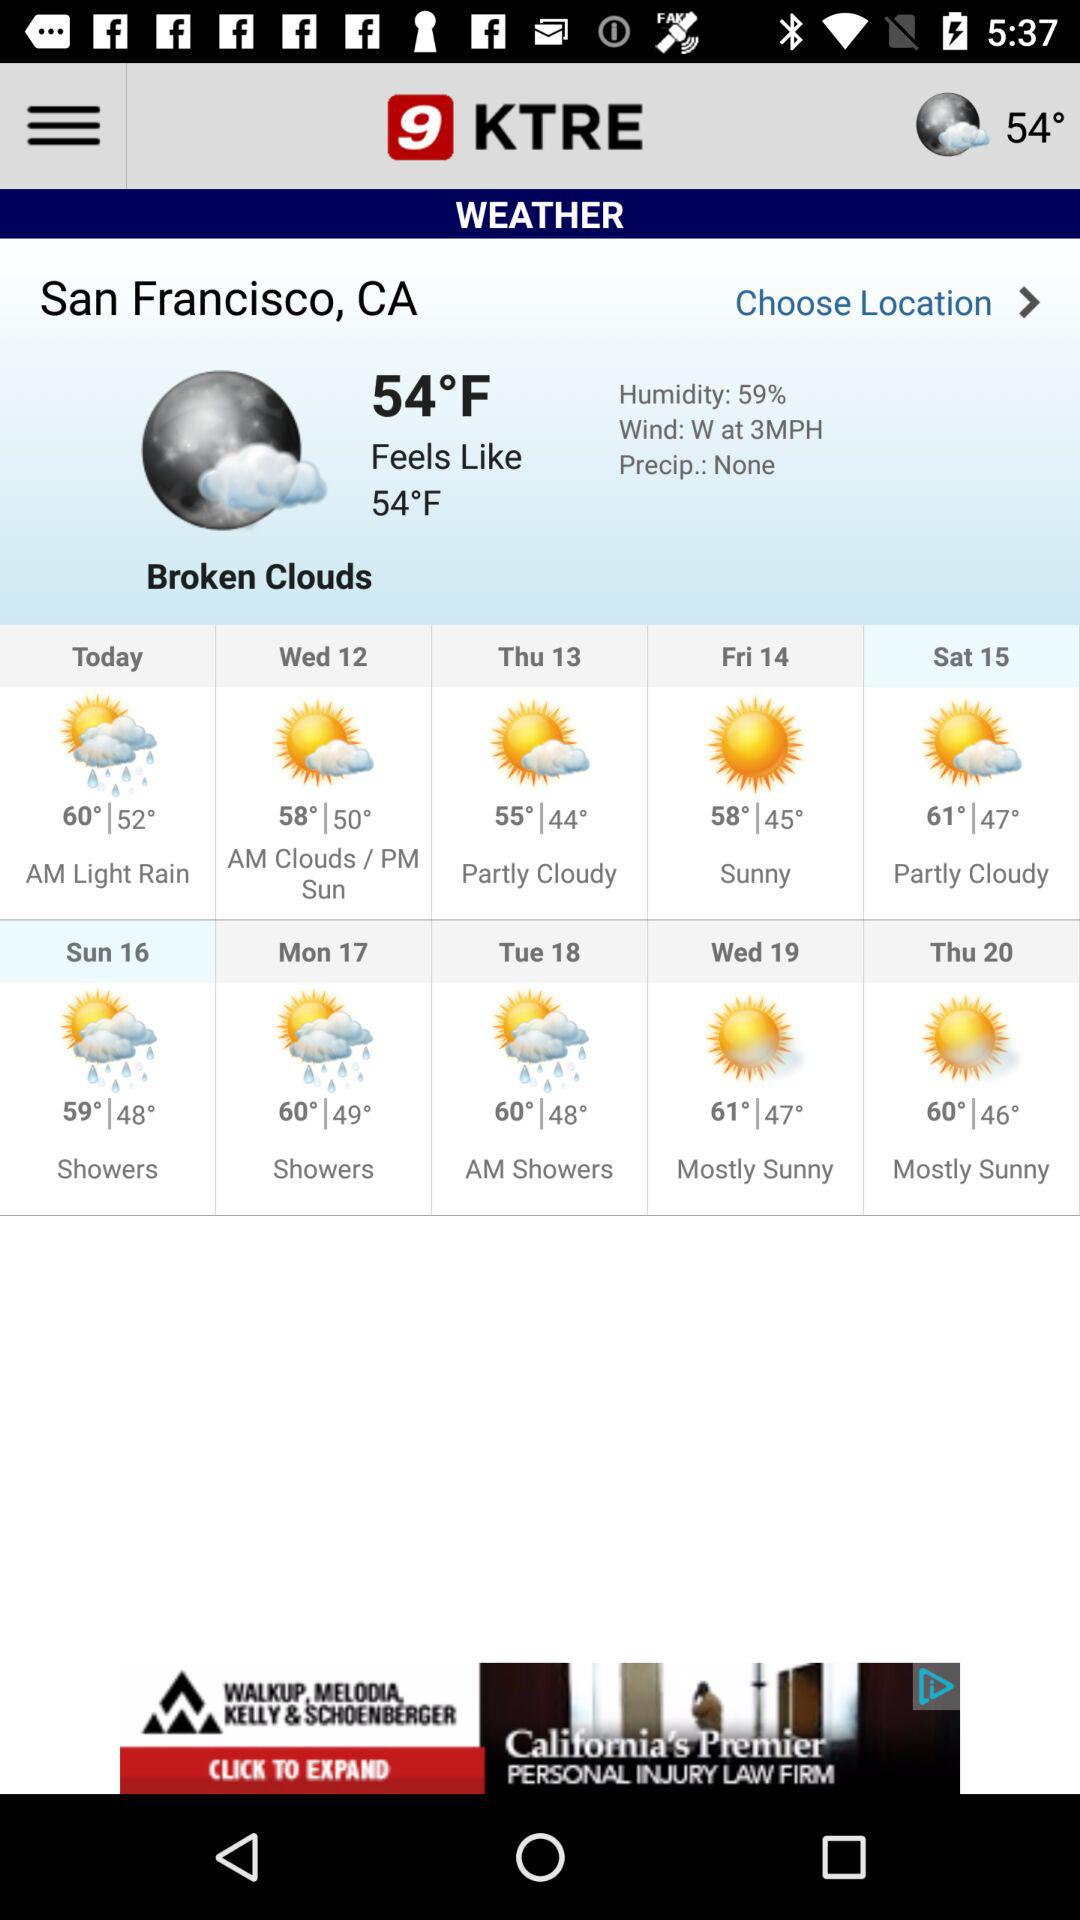How many days are there in the next 5 days?
Answer the question using a single word or phrase. 5 